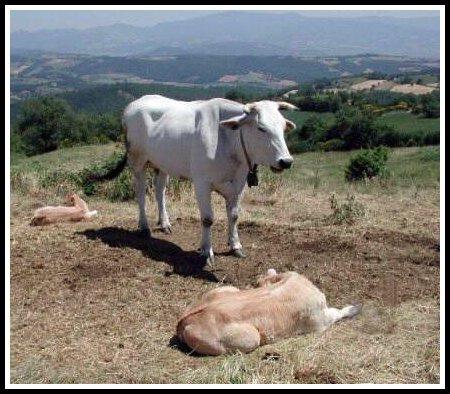Is this the only cow in the land?
Write a very short answer. No. Why can't this white cow relax?
Short answer required. Hungry. What is tied around the cow's neck?
Short answer required. Bell. Is the cow able to roam freely?
Quick response, please. Yes. Is there any farmland nearby?
Short answer required. Yes. 